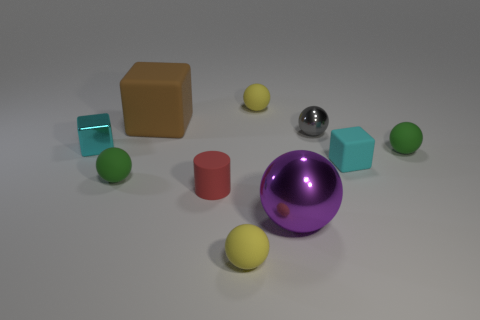Subtract all purple balls. How many balls are left? 5 Subtract all big spheres. How many spheres are left? 5 Subtract all purple spheres. Subtract all cyan cylinders. How many spheres are left? 5 Subtract all cylinders. How many objects are left? 9 Add 3 tiny cyan metallic things. How many tiny cyan metallic things exist? 4 Subtract 0 gray cubes. How many objects are left? 10 Subtract all small red matte objects. Subtract all purple metallic things. How many objects are left? 8 Add 4 cyan shiny things. How many cyan shiny things are left? 5 